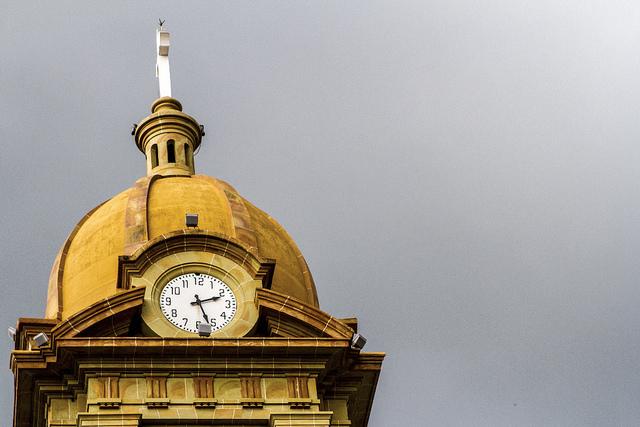What is at the very top of the clock?
Short answer required. Cross. What time does the clock show?
Quick response, please. 2:27. What color is the tower?
Answer briefly. Yellow. What time is on the clock?
Answer briefly. 2:27. 